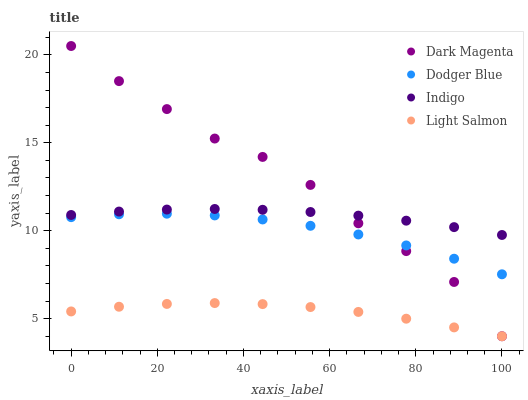Does Light Salmon have the minimum area under the curve?
Answer yes or no. Yes. Does Dark Magenta have the maximum area under the curve?
Answer yes or no. Yes. Does Dodger Blue have the minimum area under the curve?
Answer yes or no. No. Does Dodger Blue have the maximum area under the curve?
Answer yes or no. No. Is Indigo the smoothest?
Answer yes or no. Yes. Is Dark Magenta the roughest?
Answer yes or no. Yes. Is Light Salmon the smoothest?
Answer yes or no. No. Is Light Salmon the roughest?
Answer yes or no. No. Does Light Salmon have the lowest value?
Answer yes or no. Yes. Does Dodger Blue have the lowest value?
Answer yes or no. No. Does Dark Magenta have the highest value?
Answer yes or no. Yes. Does Dodger Blue have the highest value?
Answer yes or no. No. Is Light Salmon less than Dodger Blue?
Answer yes or no. Yes. Is Indigo greater than Dodger Blue?
Answer yes or no. Yes. Does Dark Magenta intersect Light Salmon?
Answer yes or no. Yes. Is Dark Magenta less than Light Salmon?
Answer yes or no. No. Is Dark Magenta greater than Light Salmon?
Answer yes or no. No. Does Light Salmon intersect Dodger Blue?
Answer yes or no. No. 